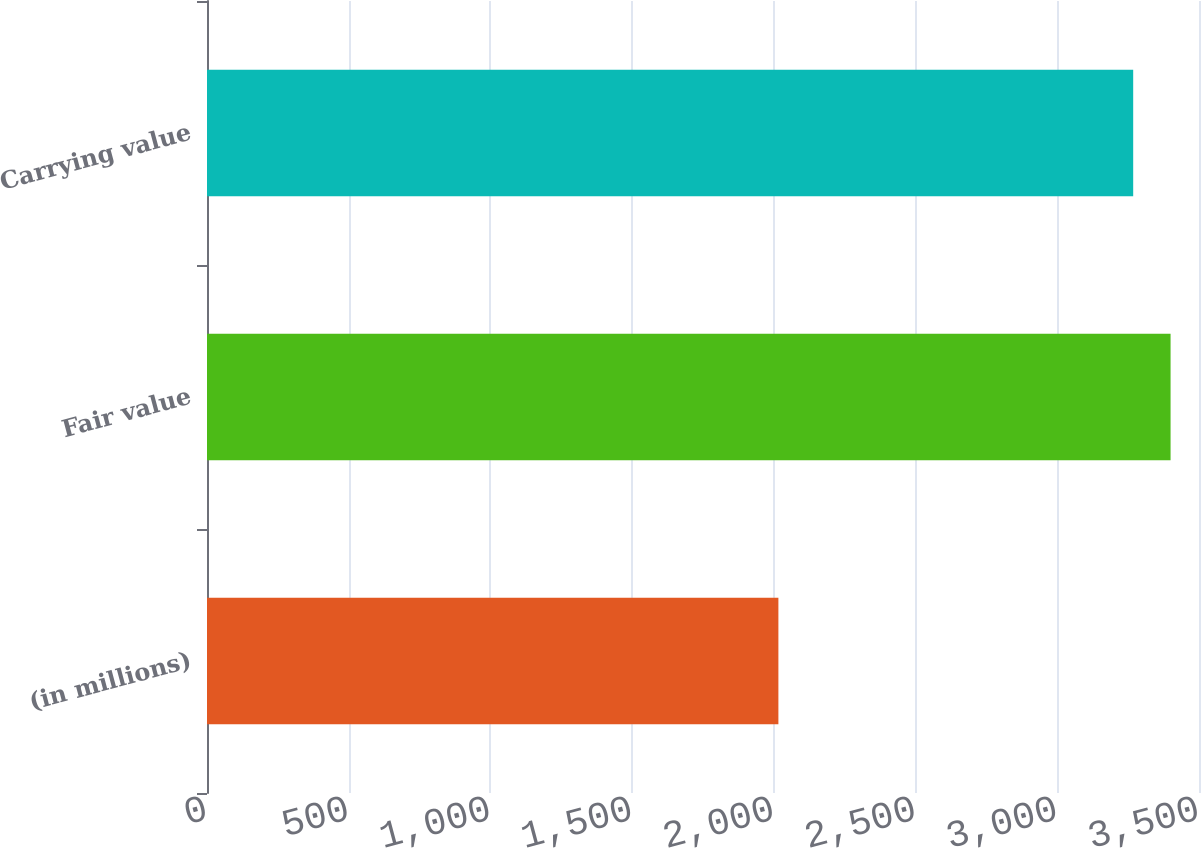<chart> <loc_0><loc_0><loc_500><loc_500><bar_chart><fcel>(in millions)<fcel>Fair value<fcel>Carrying value<nl><fcel>2016<fcel>3399.68<fcel>3267.8<nl></chart> 